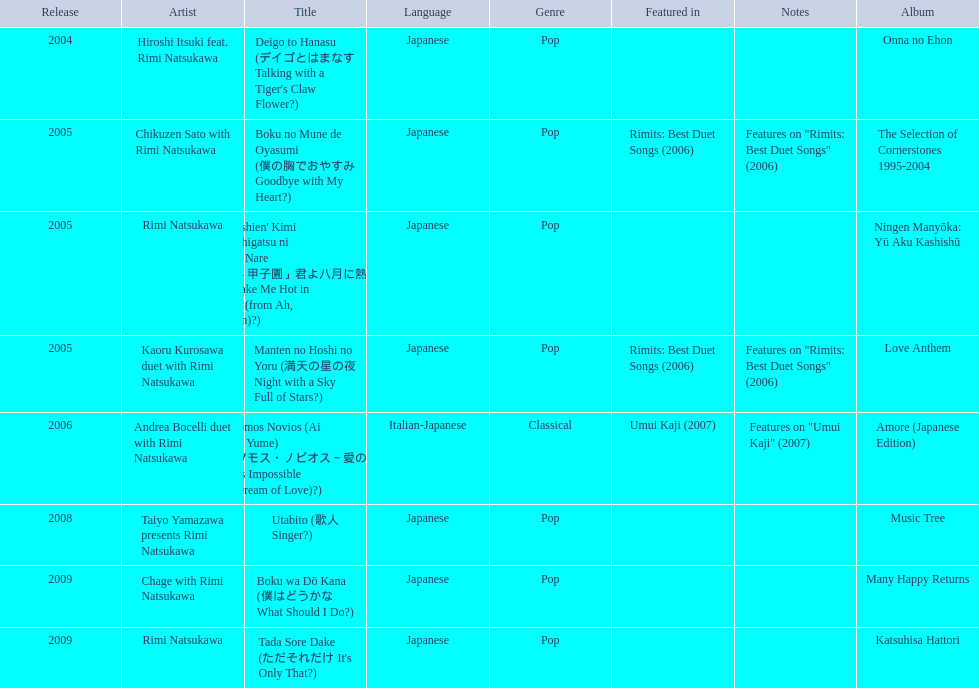Which was not released in 2004, onna no ehon or music tree? Music Tree. 